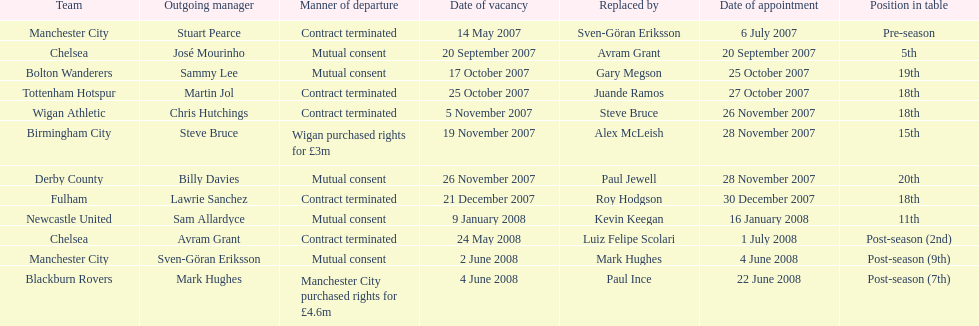Avram grant was with chelsea for at least how many years? 1. 